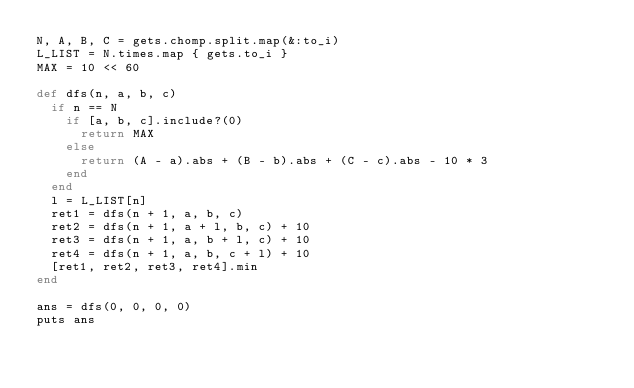<code> <loc_0><loc_0><loc_500><loc_500><_Ruby_>N, A, B, C = gets.chomp.split.map(&:to_i)
L_LIST = N.times.map { gets.to_i }
MAX = 10 << 60

def dfs(n, a, b, c)
  if n == N
    if [a, b, c].include?(0)
      return MAX
    else
      return (A - a).abs + (B - b).abs + (C - c).abs - 10 * 3
    end
  end
  l = L_LIST[n]
  ret1 = dfs(n + 1, a, b, c)
  ret2 = dfs(n + 1, a + l, b, c) + 10
  ret3 = dfs(n + 1, a, b + l, c) + 10
  ret4 = dfs(n + 1, a, b, c + l) + 10
  [ret1, ret2, ret3, ret4].min
end

ans = dfs(0, 0, 0, 0)
puts ans
</code> 